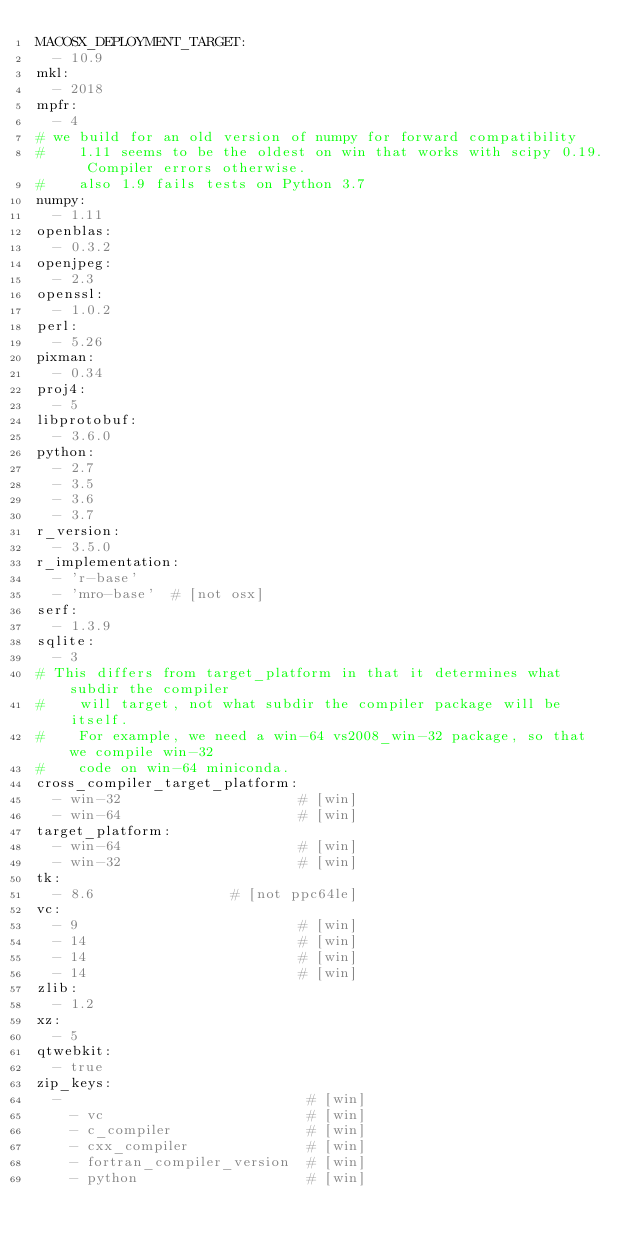<code> <loc_0><loc_0><loc_500><loc_500><_YAML_>MACOSX_DEPLOYMENT_TARGET:
  - 10.9
mkl:
  - 2018
mpfr:
  - 4
# we build for an old version of numpy for forward compatibility
#    1.11 seems to be the oldest on win that works with scipy 0.19.  Compiler errors otherwise.
#    also 1.9 fails tests on Python 3.7
numpy:
  - 1.11
openblas:
  - 0.3.2
openjpeg:
  - 2.3
openssl:
  - 1.0.2
perl:
  - 5.26
pixman:
  - 0.34
proj4:
  - 5
libprotobuf:
  - 3.6.0
python:
  - 2.7
  - 3.5
  - 3.6
  - 3.7
r_version:
  - 3.5.0
r_implementation:
  - 'r-base'
  - 'mro-base'  # [not osx]
serf:
  - 1.3.9
sqlite:
  - 3
# This differs from target_platform in that it determines what subdir the compiler
#    will target, not what subdir the compiler package will be itself.
#    For example, we need a win-64 vs2008_win-32 package, so that we compile win-32
#    code on win-64 miniconda.
cross_compiler_target_platform:
  - win-32                     # [win]
  - win-64                     # [win]
target_platform:
  - win-64                     # [win]
  - win-32                     # [win]
tk:
  - 8.6                # [not ppc64le]
vc:
  - 9                          # [win]
  - 14                         # [win]
  - 14                         # [win]
  - 14                         # [win]
zlib:
  - 1.2
xz:
  - 5
qtwebkit:
  - true
zip_keys:
  -                             # [win]
    - vc                        # [win]
    - c_compiler                # [win]
    - cxx_compiler              # [win]
    - fortran_compiler_version  # [win]
    - python                    # [win]
</code> 